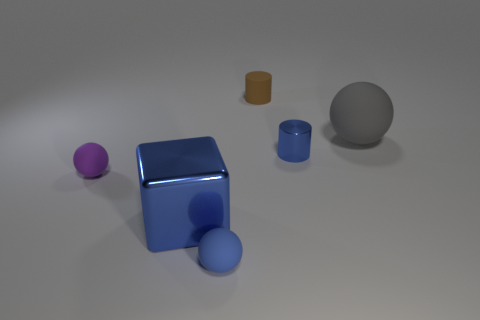Can you estimate the proportions of the objects compared to each other? Certainly! The largest object looks to be the grey sphere, followed by the blue box. The purple ball is the smallest object. The blue cylinder is slightly taller than it is wide, and the brown cylinder is the shortest object. The blue ball seems to have a diameter just below half the height of the blue box. 